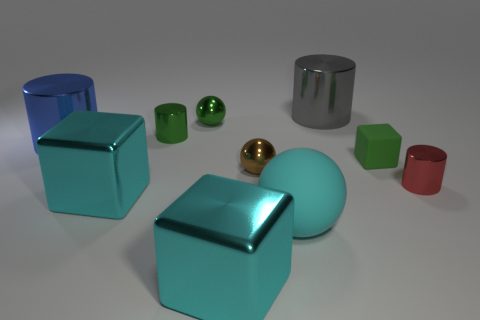Subtract all tiny shiny spheres. How many spheres are left? 1 Add 9 brown shiny spheres. How many brown shiny spheres exist? 10 Subtract all green cylinders. How many cylinders are left? 3 Subtract 0 brown blocks. How many objects are left? 10 Subtract all blocks. How many objects are left? 7 Subtract all purple balls. Subtract all green cylinders. How many balls are left? 3 Subtract all red cylinders. How many green blocks are left? 1 Subtract all big blue matte blocks. Subtract all tiny green shiny spheres. How many objects are left? 9 Add 2 large cyan matte balls. How many large cyan matte balls are left? 3 